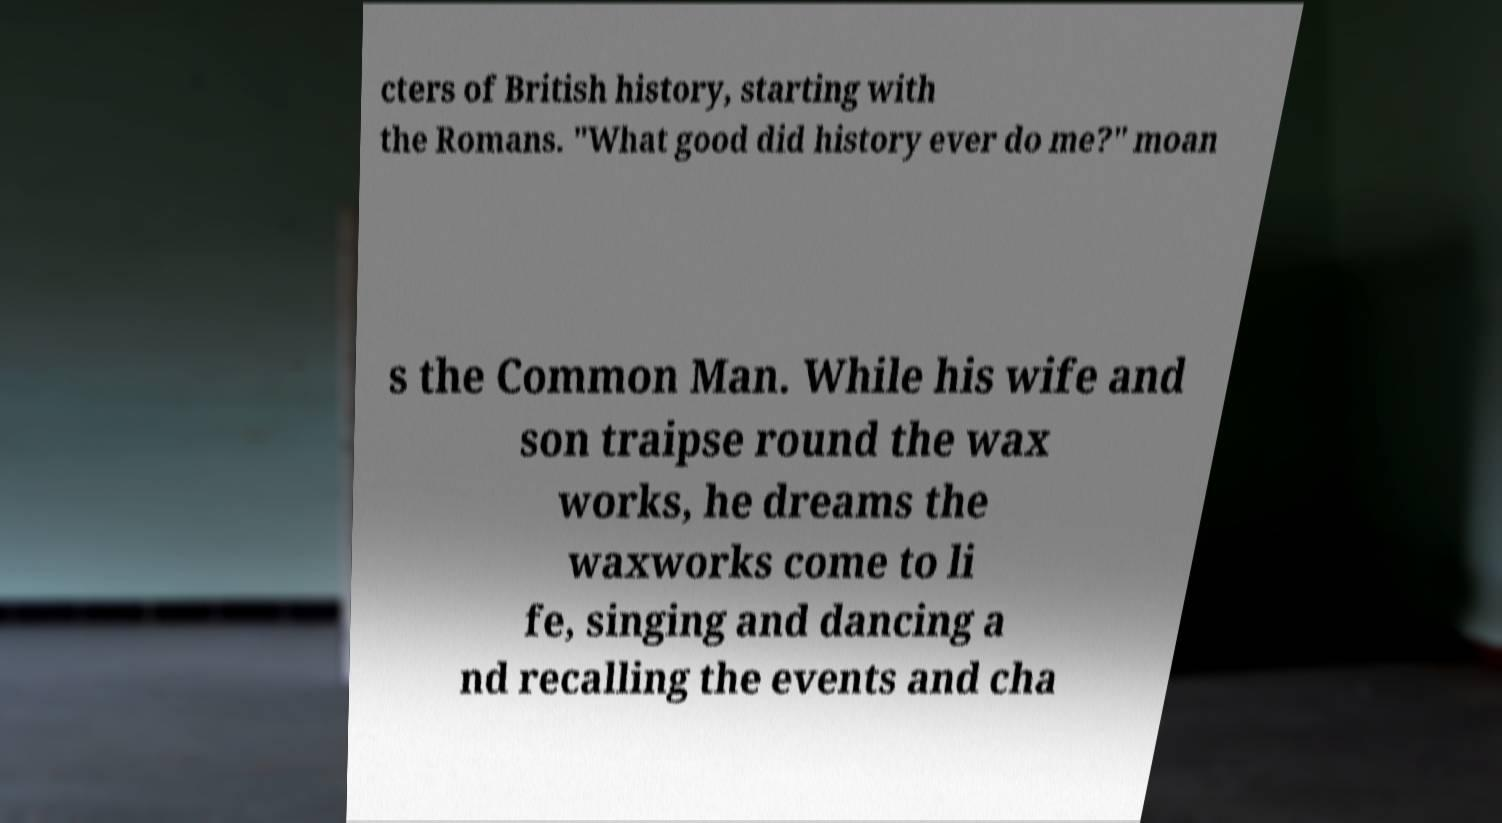Can you accurately transcribe the text from the provided image for me? cters of British history, starting with the Romans. "What good did history ever do me?" moan s the Common Man. While his wife and son traipse round the wax works, he dreams the waxworks come to li fe, singing and dancing a nd recalling the events and cha 